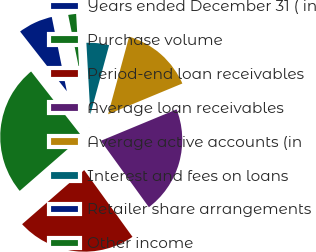Convert chart. <chart><loc_0><loc_0><loc_500><loc_500><pie_chart><fcel>Years ended December 31 ( in<fcel>Purchase volume<fcel>Period-end loan receivables<fcel>Average loan receivables<fcel>Average active accounts (in<fcel>Interest and fees on loans<fcel>Retailer share arrangements<fcel>Other income<nl><fcel>7.38%<fcel>25.84%<fcel>23.56%<fcel>21.29%<fcel>14.53%<fcel>5.1%<fcel>0.01%<fcel>2.29%<nl></chart> 